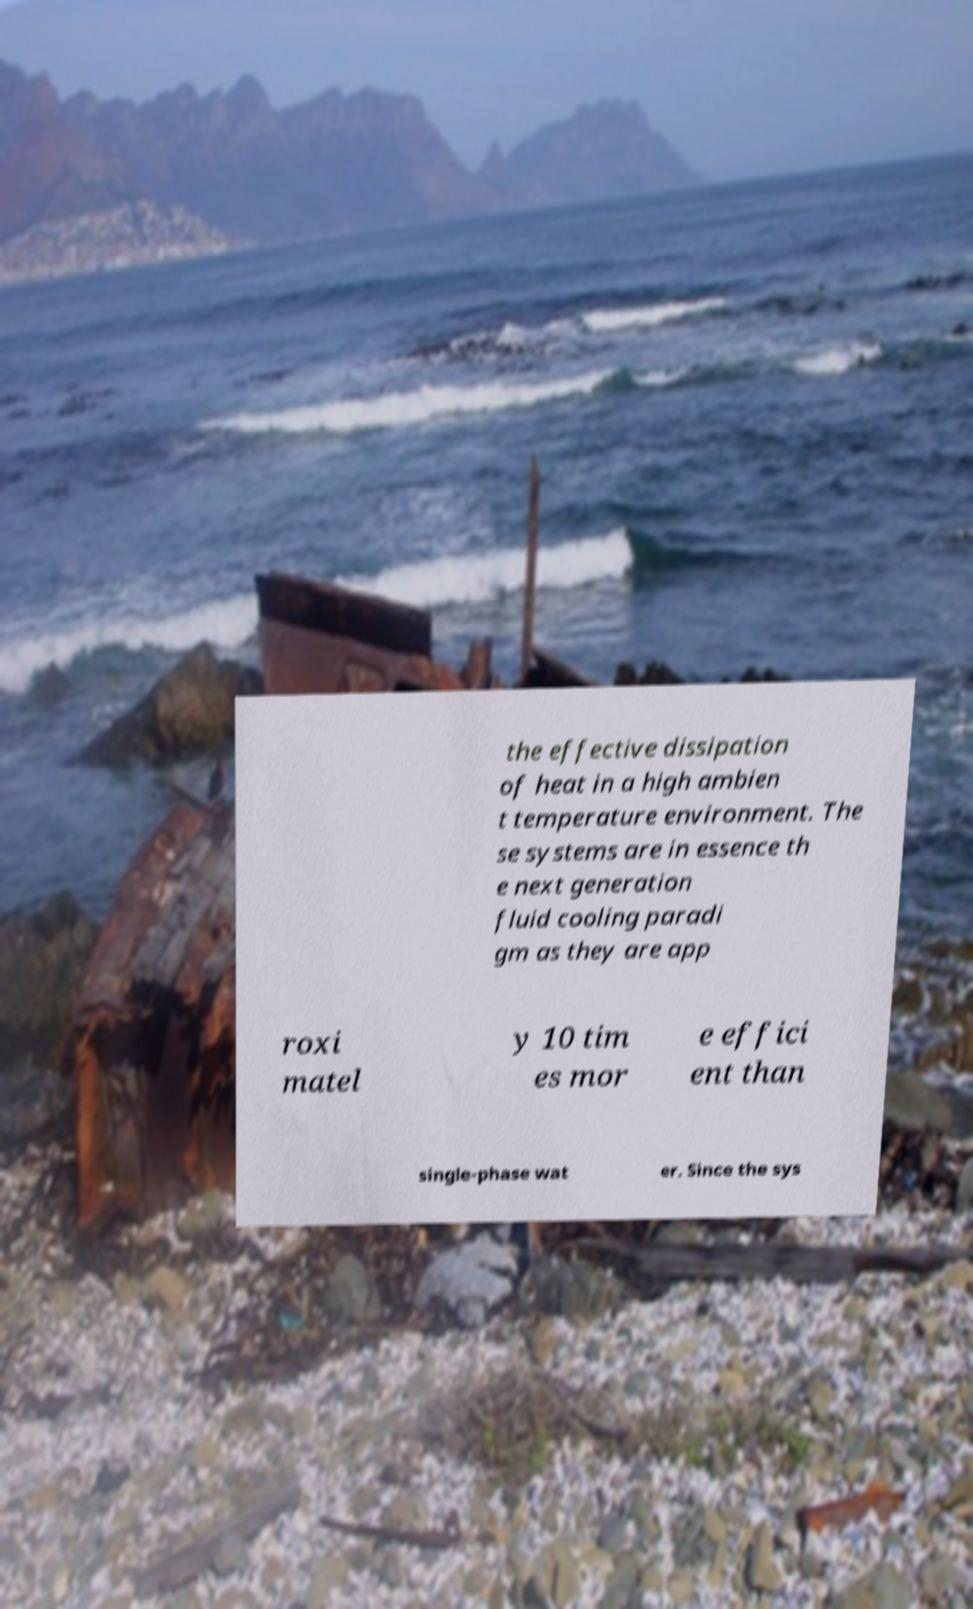Can you read and provide the text displayed in the image?This photo seems to have some interesting text. Can you extract and type it out for me? the effective dissipation of heat in a high ambien t temperature environment. The se systems are in essence th e next generation fluid cooling paradi gm as they are app roxi matel y 10 tim es mor e effici ent than single-phase wat er. Since the sys 